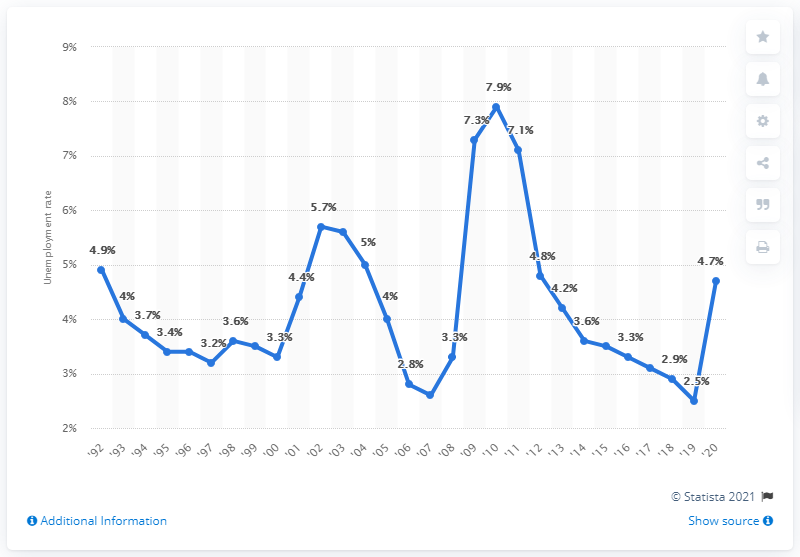Give some essential details in this illustration. In 2020, Utah's unemployment rate was 4.7%. In 2010, Utah's highest unemployment rate was 7.9%. 